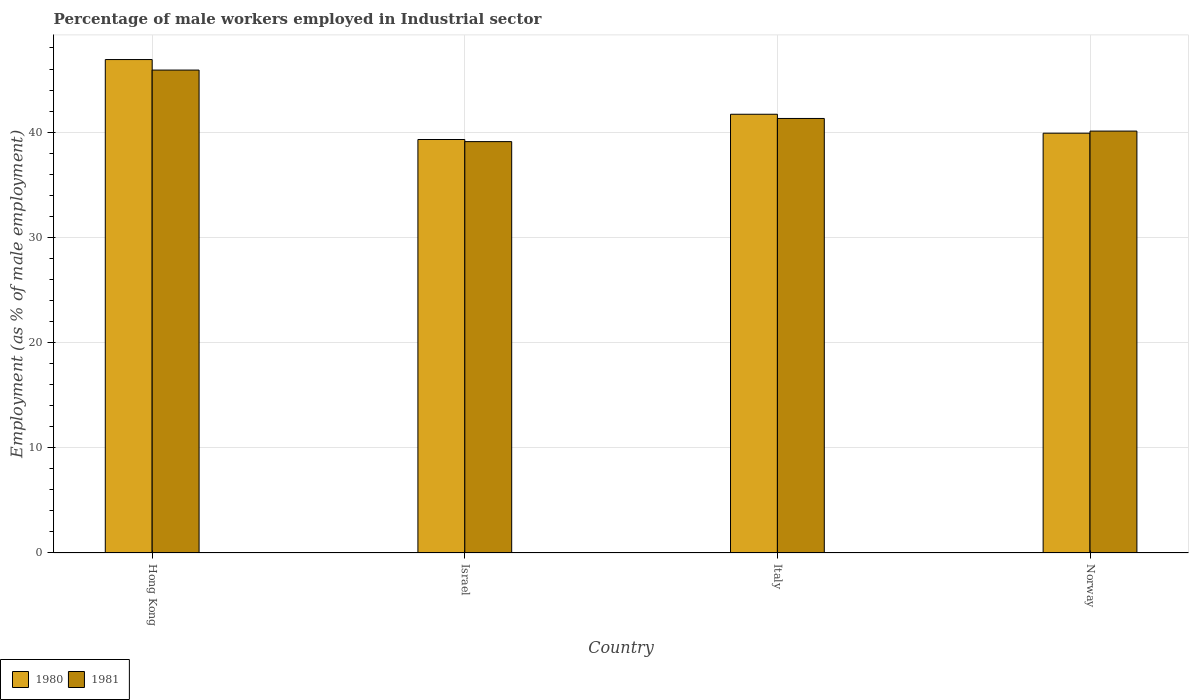Are the number of bars per tick equal to the number of legend labels?
Provide a succinct answer. Yes. Are the number of bars on each tick of the X-axis equal?
Your response must be concise. Yes. How many bars are there on the 3rd tick from the left?
Offer a terse response. 2. How many bars are there on the 1st tick from the right?
Keep it short and to the point. 2. What is the label of the 3rd group of bars from the left?
Give a very brief answer. Italy. What is the percentage of male workers employed in Industrial sector in 1981 in Hong Kong?
Give a very brief answer. 45.9. Across all countries, what is the maximum percentage of male workers employed in Industrial sector in 1981?
Make the answer very short. 45.9. Across all countries, what is the minimum percentage of male workers employed in Industrial sector in 1980?
Keep it short and to the point. 39.3. In which country was the percentage of male workers employed in Industrial sector in 1980 maximum?
Offer a very short reply. Hong Kong. What is the total percentage of male workers employed in Industrial sector in 1981 in the graph?
Your response must be concise. 166.4. What is the difference between the percentage of male workers employed in Industrial sector in 1981 in Italy and that in Norway?
Ensure brevity in your answer.  1.2. What is the difference between the percentage of male workers employed in Industrial sector in 1980 in Hong Kong and the percentage of male workers employed in Industrial sector in 1981 in Italy?
Offer a very short reply. 5.6. What is the average percentage of male workers employed in Industrial sector in 1980 per country?
Offer a very short reply. 41.95. What is the difference between the percentage of male workers employed in Industrial sector of/in 1981 and percentage of male workers employed in Industrial sector of/in 1980 in Israel?
Offer a very short reply. -0.2. In how many countries, is the percentage of male workers employed in Industrial sector in 1980 greater than 2 %?
Provide a short and direct response. 4. What is the ratio of the percentage of male workers employed in Industrial sector in 1981 in Hong Kong to that in Israel?
Offer a very short reply. 1.17. Is the percentage of male workers employed in Industrial sector in 1980 in Hong Kong less than that in Norway?
Make the answer very short. No. Is the difference between the percentage of male workers employed in Industrial sector in 1981 in Israel and Italy greater than the difference between the percentage of male workers employed in Industrial sector in 1980 in Israel and Italy?
Offer a terse response. Yes. What is the difference between the highest and the second highest percentage of male workers employed in Industrial sector in 1981?
Offer a very short reply. -1.2. What is the difference between the highest and the lowest percentage of male workers employed in Industrial sector in 1981?
Offer a very short reply. 6.8. What does the 2nd bar from the left in Norway represents?
Your response must be concise. 1981. What does the 2nd bar from the right in Norway represents?
Give a very brief answer. 1980. Are all the bars in the graph horizontal?
Provide a short and direct response. No. How many countries are there in the graph?
Give a very brief answer. 4. Where does the legend appear in the graph?
Offer a very short reply. Bottom left. How are the legend labels stacked?
Keep it short and to the point. Horizontal. What is the title of the graph?
Keep it short and to the point. Percentage of male workers employed in Industrial sector. What is the label or title of the X-axis?
Ensure brevity in your answer.  Country. What is the label or title of the Y-axis?
Provide a short and direct response. Employment (as % of male employment). What is the Employment (as % of male employment) in 1980 in Hong Kong?
Provide a succinct answer. 46.9. What is the Employment (as % of male employment) of 1981 in Hong Kong?
Give a very brief answer. 45.9. What is the Employment (as % of male employment) of 1980 in Israel?
Offer a very short reply. 39.3. What is the Employment (as % of male employment) of 1981 in Israel?
Your answer should be compact. 39.1. What is the Employment (as % of male employment) of 1980 in Italy?
Your answer should be very brief. 41.7. What is the Employment (as % of male employment) in 1981 in Italy?
Your response must be concise. 41.3. What is the Employment (as % of male employment) in 1980 in Norway?
Provide a short and direct response. 39.9. What is the Employment (as % of male employment) in 1981 in Norway?
Provide a succinct answer. 40.1. Across all countries, what is the maximum Employment (as % of male employment) in 1980?
Offer a terse response. 46.9. Across all countries, what is the maximum Employment (as % of male employment) of 1981?
Keep it short and to the point. 45.9. Across all countries, what is the minimum Employment (as % of male employment) of 1980?
Keep it short and to the point. 39.3. Across all countries, what is the minimum Employment (as % of male employment) in 1981?
Your response must be concise. 39.1. What is the total Employment (as % of male employment) of 1980 in the graph?
Offer a very short reply. 167.8. What is the total Employment (as % of male employment) of 1981 in the graph?
Ensure brevity in your answer.  166.4. What is the difference between the Employment (as % of male employment) in 1981 in Hong Kong and that in Israel?
Offer a terse response. 6.8. What is the difference between the Employment (as % of male employment) of 1981 in Hong Kong and that in Norway?
Provide a succinct answer. 5.8. What is the difference between the Employment (as % of male employment) of 1980 in Israel and that in Italy?
Your answer should be very brief. -2.4. What is the difference between the Employment (as % of male employment) of 1981 in Israel and that in Italy?
Ensure brevity in your answer.  -2.2. What is the difference between the Employment (as % of male employment) in 1980 in Israel and that in Norway?
Your response must be concise. -0.6. What is the difference between the Employment (as % of male employment) in 1980 in Italy and that in Norway?
Your answer should be very brief. 1.8. What is the difference between the Employment (as % of male employment) in 1981 in Italy and that in Norway?
Keep it short and to the point. 1.2. What is the difference between the Employment (as % of male employment) of 1980 in Hong Kong and the Employment (as % of male employment) of 1981 in Italy?
Provide a succinct answer. 5.6. What is the difference between the Employment (as % of male employment) in 1980 in Hong Kong and the Employment (as % of male employment) in 1981 in Norway?
Keep it short and to the point. 6.8. What is the difference between the Employment (as % of male employment) in 1980 in Israel and the Employment (as % of male employment) in 1981 in Norway?
Make the answer very short. -0.8. What is the difference between the Employment (as % of male employment) of 1980 in Italy and the Employment (as % of male employment) of 1981 in Norway?
Make the answer very short. 1.6. What is the average Employment (as % of male employment) in 1980 per country?
Your answer should be compact. 41.95. What is the average Employment (as % of male employment) in 1981 per country?
Make the answer very short. 41.6. What is the difference between the Employment (as % of male employment) in 1980 and Employment (as % of male employment) in 1981 in Hong Kong?
Give a very brief answer. 1. What is the difference between the Employment (as % of male employment) in 1980 and Employment (as % of male employment) in 1981 in Israel?
Offer a very short reply. 0.2. What is the difference between the Employment (as % of male employment) of 1980 and Employment (as % of male employment) of 1981 in Norway?
Provide a short and direct response. -0.2. What is the ratio of the Employment (as % of male employment) of 1980 in Hong Kong to that in Israel?
Provide a short and direct response. 1.19. What is the ratio of the Employment (as % of male employment) of 1981 in Hong Kong to that in Israel?
Make the answer very short. 1.17. What is the ratio of the Employment (as % of male employment) in 1980 in Hong Kong to that in Italy?
Your answer should be very brief. 1.12. What is the ratio of the Employment (as % of male employment) of 1981 in Hong Kong to that in Italy?
Your answer should be compact. 1.11. What is the ratio of the Employment (as % of male employment) in 1980 in Hong Kong to that in Norway?
Your response must be concise. 1.18. What is the ratio of the Employment (as % of male employment) of 1981 in Hong Kong to that in Norway?
Your answer should be compact. 1.14. What is the ratio of the Employment (as % of male employment) of 1980 in Israel to that in Italy?
Offer a terse response. 0.94. What is the ratio of the Employment (as % of male employment) of 1981 in Israel to that in Italy?
Your answer should be compact. 0.95. What is the ratio of the Employment (as % of male employment) in 1981 in Israel to that in Norway?
Offer a very short reply. 0.98. What is the ratio of the Employment (as % of male employment) of 1980 in Italy to that in Norway?
Provide a succinct answer. 1.05. What is the ratio of the Employment (as % of male employment) of 1981 in Italy to that in Norway?
Your answer should be compact. 1.03. What is the difference between the highest and the lowest Employment (as % of male employment) in 1980?
Provide a short and direct response. 7.6. 